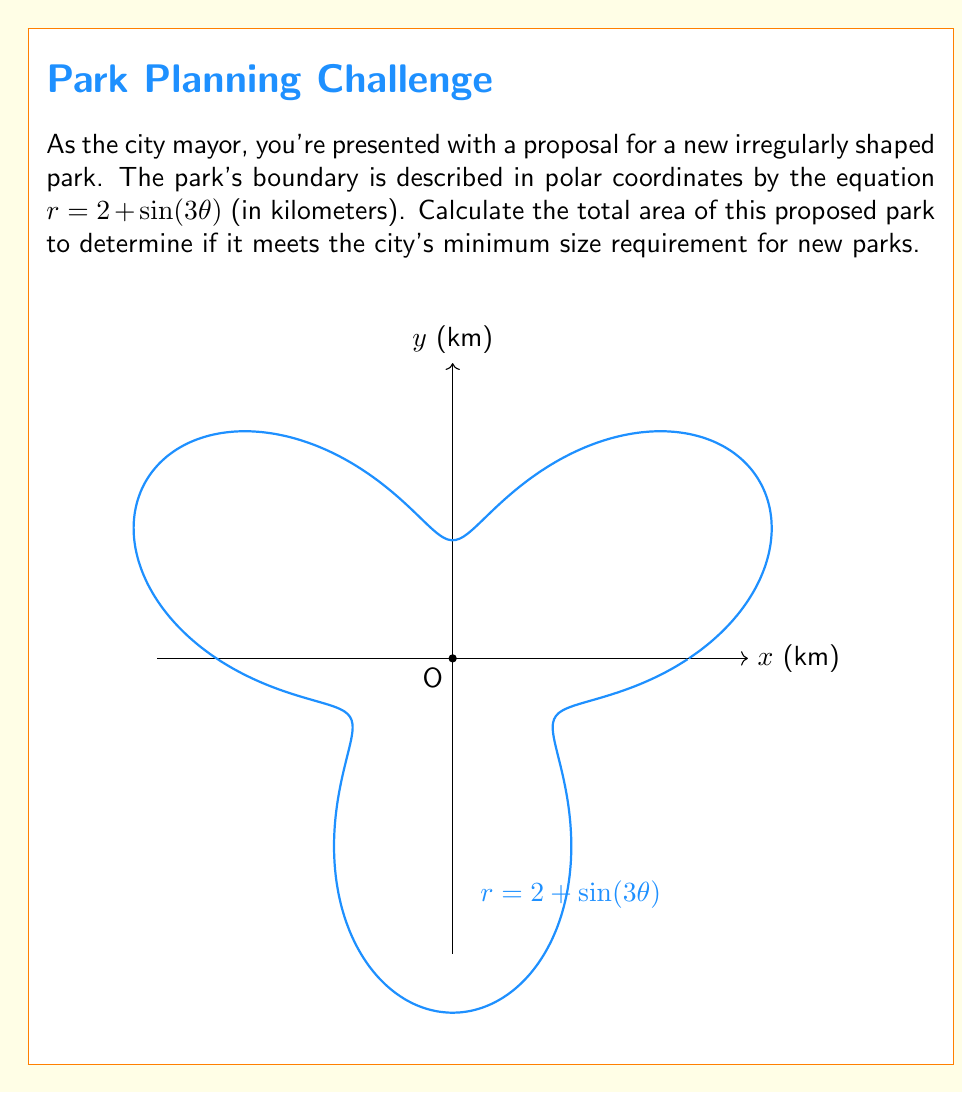Provide a solution to this math problem. To calculate the area of this irregularly shaped park, we'll use the formula for area in polar coordinates:

$$A = \frac{1}{2} \int_{0}^{2\pi} r^2(\theta) d\theta$$

Where $r(\theta) = 2 + \sin(3\theta)$

Steps:
1) Substitute $r(\theta)$ into the formula:
   $$A = \frac{1}{2} \int_{0}^{2\pi} (2 + \sin(3\theta))^2 d\theta$$

2) Expand the squared term:
   $$A = \frac{1}{2} \int_{0}^{2\pi} (4 + 4\sin(3\theta) + \sin^2(3\theta)) d\theta$$

3) Integrate each term:
   $$A = \frac{1}{2} \left[4\theta + \frac{4}{3}\cos(3\theta) + \frac{\theta}{2} - \frac{\sin(6\theta)}{12}\right]_{0}^{2\pi}$$

4) Evaluate the integral:
   $$A = \frac{1}{2} \left[(4 \cdot 2\pi + \frac{2\pi}{2}) - (0)\right] = \frac{1}{2} (8\pi + \pi) = \frac{9\pi}{2}$$

5) The result is in square kilometers. To convert to hectares (ha), multiply by 100:
   $$A_{ha} = \frac{9\pi}{2} \cdot 100 \approx 1413.72 \text{ ha}$$
Answer: $1413.72 \text{ hectares}$ 